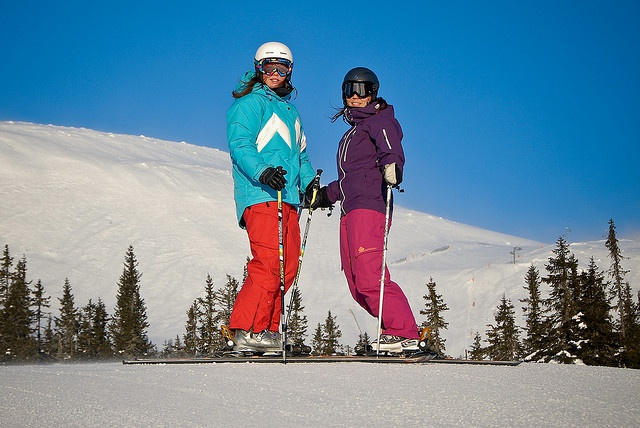Describe the objects in this image and their specific colors. I can see people in blue, red, teal, lightblue, and ivory tones, people in blue, purple, brown, and black tones, skis in blue, gray, black, and darkgray tones, skis in blue, black, gray, and darkgray tones, and skis in blue, black, gray, and darkgray tones in this image. 